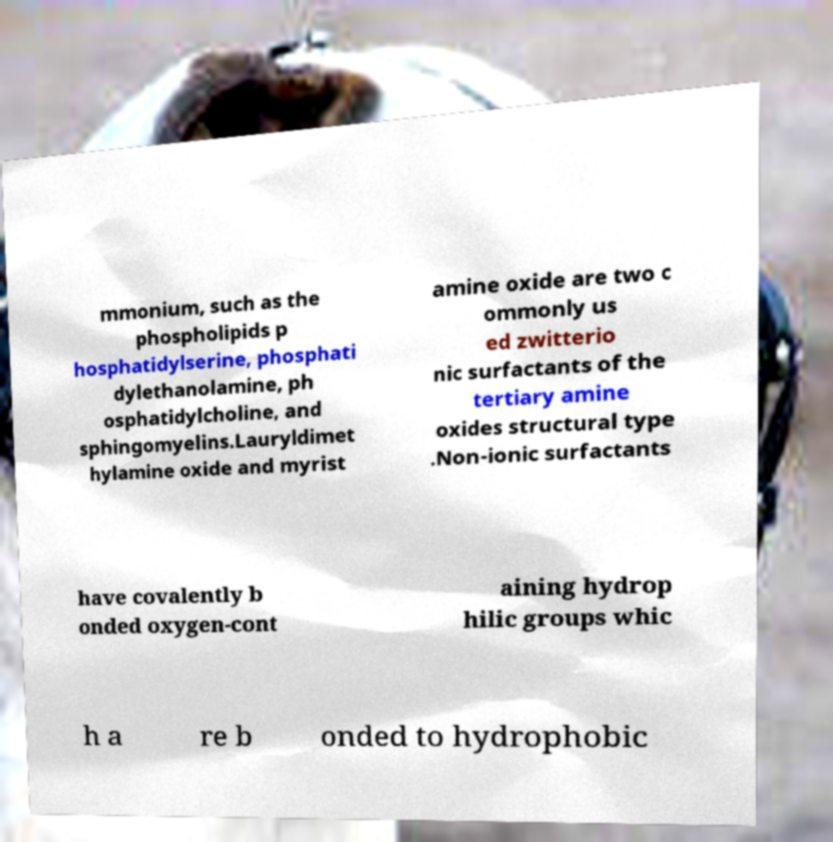There's text embedded in this image that I need extracted. Can you transcribe it verbatim? mmonium, such as the phospholipids p hosphatidylserine, phosphati dylethanolamine, ph osphatidylcholine, and sphingomyelins.Lauryldimet hylamine oxide and myrist amine oxide are two c ommonly us ed zwitterio nic surfactants of the tertiary amine oxides structural type .Non-ionic surfactants have covalently b onded oxygen-cont aining hydrop hilic groups whic h a re b onded to hydrophobic 